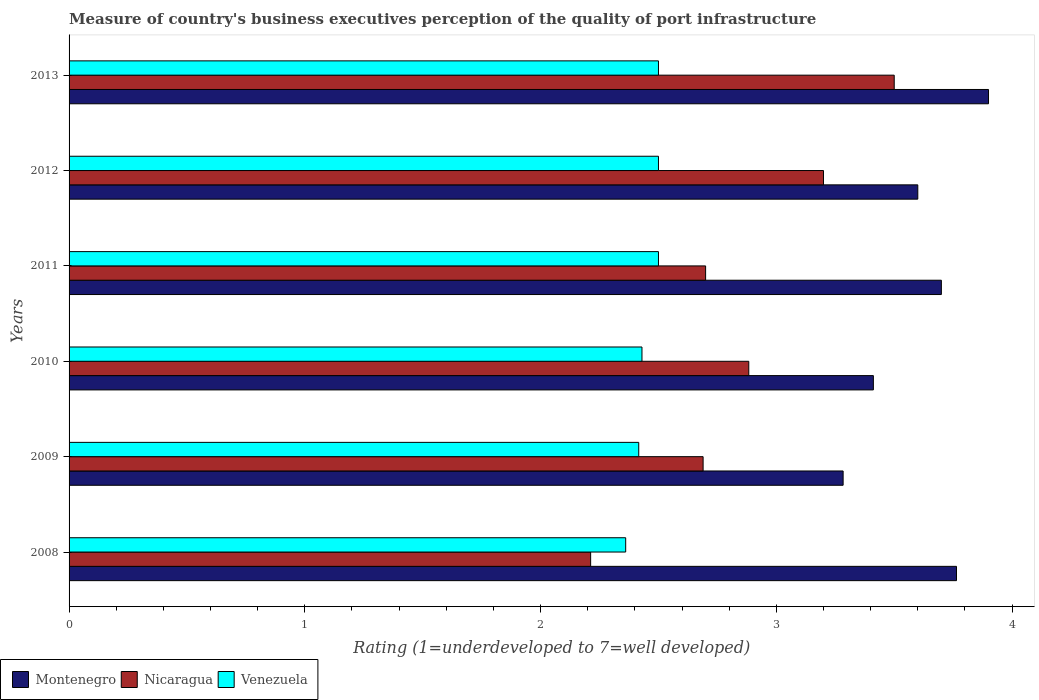How many different coloured bars are there?
Provide a short and direct response. 3. How many groups of bars are there?
Offer a terse response. 6. Are the number of bars per tick equal to the number of legend labels?
Make the answer very short. Yes. How many bars are there on the 2nd tick from the bottom?
Keep it short and to the point. 3. In how many cases, is the number of bars for a given year not equal to the number of legend labels?
Offer a very short reply. 0. What is the ratings of the quality of port infrastructure in Venezuela in 2008?
Your answer should be compact. 2.36. Across all years, what is the maximum ratings of the quality of port infrastructure in Nicaragua?
Keep it short and to the point. 3.5. Across all years, what is the minimum ratings of the quality of port infrastructure in Nicaragua?
Keep it short and to the point. 2.21. What is the total ratings of the quality of port infrastructure in Venezuela in the graph?
Your answer should be very brief. 14.71. What is the difference between the ratings of the quality of port infrastructure in Montenegro in 2012 and that in 2013?
Ensure brevity in your answer.  -0.3. What is the difference between the ratings of the quality of port infrastructure in Montenegro in 2011 and the ratings of the quality of port infrastructure in Nicaragua in 2013?
Offer a terse response. 0.2. What is the average ratings of the quality of port infrastructure in Montenegro per year?
Provide a short and direct response. 3.61. In the year 2012, what is the difference between the ratings of the quality of port infrastructure in Nicaragua and ratings of the quality of port infrastructure in Montenegro?
Offer a very short reply. -0.4. What is the ratio of the ratings of the quality of port infrastructure in Montenegro in 2009 to that in 2012?
Offer a terse response. 0.91. What is the difference between the highest and the second highest ratings of the quality of port infrastructure in Nicaragua?
Ensure brevity in your answer.  0.3. What is the difference between the highest and the lowest ratings of the quality of port infrastructure in Nicaragua?
Your answer should be very brief. 1.29. In how many years, is the ratings of the quality of port infrastructure in Nicaragua greater than the average ratings of the quality of port infrastructure in Nicaragua taken over all years?
Provide a short and direct response. 3. What does the 3rd bar from the top in 2012 represents?
Ensure brevity in your answer.  Montenegro. What does the 2nd bar from the bottom in 2013 represents?
Your answer should be compact. Nicaragua. How many years are there in the graph?
Provide a short and direct response. 6. Are the values on the major ticks of X-axis written in scientific E-notation?
Provide a succinct answer. No. Does the graph contain any zero values?
Provide a succinct answer. No. Does the graph contain grids?
Offer a terse response. No. Where does the legend appear in the graph?
Keep it short and to the point. Bottom left. How many legend labels are there?
Your answer should be very brief. 3. How are the legend labels stacked?
Ensure brevity in your answer.  Horizontal. What is the title of the graph?
Ensure brevity in your answer.  Measure of country's business executives perception of the quality of port infrastructure. Does "Gambia, The" appear as one of the legend labels in the graph?
Your answer should be very brief. No. What is the label or title of the X-axis?
Keep it short and to the point. Rating (1=underdeveloped to 7=well developed). What is the label or title of the Y-axis?
Make the answer very short. Years. What is the Rating (1=underdeveloped to 7=well developed) in Montenegro in 2008?
Provide a succinct answer. 3.76. What is the Rating (1=underdeveloped to 7=well developed) in Nicaragua in 2008?
Make the answer very short. 2.21. What is the Rating (1=underdeveloped to 7=well developed) in Venezuela in 2008?
Ensure brevity in your answer.  2.36. What is the Rating (1=underdeveloped to 7=well developed) in Montenegro in 2009?
Ensure brevity in your answer.  3.28. What is the Rating (1=underdeveloped to 7=well developed) of Nicaragua in 2009?
Offer a terse response. 2.69. What is the Rating (1=underdeveloped to 7=well developed) of Venezuela in 2009?
Offer a very short reply. 2.42. What is the Rating (1=underdeveloped to 7=well developed) in Montenegro in 2010?
Your response must be concise. 3.41. What is the Rating (1=underdeveloped to 7=well developed) of Nicaragua in 2010?
Your answer should be very brief. 2.88. What is the Rating (1=underdeveloped to 7=well developed) in Venezuela in 2010?
Offer a terse response. 2.43. What is the Rating (1=underdeveloped to 7=well developed) in Venezuela in 2011?
Make the answer very short. 2.5. What is the Rating (1=underdeveloped to 7=well developed) of Venezuela in 2012?
Your response must be concise. 2.5. Across all years, what is the maximum Rating (1=underdeveloped to 7=well developed) in Nicaragua?
Your answer should be very brief. 3.5. Across all years, what is the maximum Rating (1=underdeveloped to 7=well developed) of Venezuela?
Provide a short and direct response. 2.5. Across all years, what is the minimum Rating (1=underdeveloped to 7=well developed) in Montenegro?
Make the answer very short. 3.28. Across all years, what is the minimum Rating (1=underdeveloped to 7=well developed) in Nicaragua?
Offer a very short reply. 2.21. Across all years, what is the minimum Rating (1=underdeveloped to 7=well developed) of Venezuela?
Ensure brevity in your answer.  2.36. What is the total Rating (1=underdeveloped to 7=well developed) of Montenegro in the graph?
Your answer should be very brief. 21.66. What is the total Rating (1=underdeveloped to 7=well developed) of Nicaragua in the graph?
Provide a succinct answer. 17.18. What is the total Rating (1=underdeveloped to 7=well developed) of Venezuela in the graph?
Your answer should be compact. 14.71. What is the difference between the Rating (1=underdeveloped to 7=well developed) of Montenegro in 2008 and that in 2009?
Ensure brevity in your answer.  0.48. What is the difference between the Rating (1=underdeveloped to 7=well developed) of Nicaragua in 2008 and that in 2009?
Offer a very short reply. -0.48. What is the difference between the Rating (1=underdeveloped to 7=well developed) in Venezuela in 2008 and that in 2009?
Provide a succinct answer. -0.06. What is the difference between the Rating (1=underdeveloped to 7=well developed) in Montenegro in 2008 and that in 2010?
Your answer should be very brief. 0.35. What is the difference between the Rating (1=underdeveloped to 7=well developed) of Nicaragua in 2008 and that in 2010?
Offer a terse response. -0.67. What is the difference between the Rating (1=underdeveloped to 7=well developed) of Venezuela in 2008 and that in 2010?
Your answer should be very brief. -0.07. What is the difference between the Rating (1=underdeveloped to 7=well developed) of Montenegro in 2008 and that in 2011?
Your answer should be compact. 0.06. What is the difference between the Rating (1=underdeveloped to 7=well developed) of Nicaragua in 2008 and that in 2011?
Provide a short and direct response. -0.49. What is the difference between the Rating (1=underdeveloped to 7=well developed) in Venezuela in 2008 and that in 2011?
Ensure brevity in your answer.  -0.14. What is the difference between the Rating (1=underdeveloped to 7=well developed) of Montenegro in 2008 and that in 2012?
Keep it short and to the point. 0.16. What is the difference between the Rating (1=underdeveloped to 7=well developed) in Nicaragua in 2008 and that in 2012?
Keep it short and to the point. -0.99. What is the difference between the Rating (1=underdeveloped to 7=well developed) of Venezuela in 2008 and that in 2012?
Offer a very short reply. -0.14. What is the difference between the Rating (1=underdeveloped to 7=well developed) of Montenegro in 2008 and that in 2013?
Provide a succinct answer. -0.14. What is the difference between the Rating (1=underdeveloped to 7=well developed) in Nicaragua in 2008 and that in 2013?
Keep it short and to the point. -1.29. What is the difference between the Rating (1=underdeveloped to 7=well developed) of Venezuela in 2008 and that in 2013?
Keep it short and to the point. -0.14. What is the difference between the Rating (1=underdeveloped to 7=well developed) in Montenegro in 2009 and that in 2010?
Keep it short and to the point. -0.13. What is the difference between the Rating (1=underdeveloped to 7=well developed) of Nicaragua in 2009 and that in 2010?
Your answer should be very brief. -0.19. What is the difference between the Rating (1=underdeveloped to 7=well developed) in Venezuela in 2009 and that in 2010?
Keep it short and to the point. -0.01. What is the difference between the Rating (1=underdeveloped to 7=well developed) of Montenegro in 2009 and that in 2011?
Offer a terse response. -0.42. What is the difference between the Rating (1=underdeveloped to 7=well developed) in Nicaragua in 2009 and that in 2011?
Provide a succinct answer. -0.01. What is the difference between the Rating (1=underdeveloped to 7=well developed) in Venezuela in 2009 and that in 2011?
Keep it short and to the point. -0.08. What is the difference between the Rating (1=underdeveloped to 7=well developed) of Montenegro in 2009 and that in 2012?
Give a very brief answer. -0.32. What is the difference between the Rating (1=underdeveloped to 7=well developed) in Nicaragua in 2009 and that in 2012?
Provide a short and direct response. -0.51. What is the difference between the Rating (1=underdeveloped to 7=well developed) of Venezuela in 2009 and that in 2012?
Make the answer very short. -0.08. What is the difference between the Rating (1=underdeveloped to 7=well developed) of Montenegro in 2009 and that in 2013?
Ensure brevity in your answer.  -0.62. What is the difference between the Rating (1=underdeveloped to 7=well developed) in Nicaragua in 2009 and that in 2013?
Make the answer very short. -0.81. What is the difference between the Rating (1=underdeveloped to 7=well developed) in Venezuela in 2009 and that in 2013?
Give a very brief answer. -0.08. What is the difference between the Rating (1=underdeveloped to 7=well developed) in Montenegro in 2010 and that in 2011?
Provide a succinct answer. -0.29. What is the difference between the Rating (1=underdeveloped to 7=well developed) of Nicaragua in 2010 and that in 2011?
Offer a terse response. 0.18. What is the difference between the Rating (1=underdeveloped to 7=well developed) of Venezuela in 2010 and that in 2011?
Your answer should be compact. -0.07. What is the difference between the Rating (1=underdeveloped to 7=well developed) in Montenegro in 2010 and that in 2012?
Your answer should be compact. -0.19. What is the difference between the Rating (1=underdeveloped to 7=well developed) in Nicaragua in 2010 and that in 2012?
Give a very brief answer. -0.32. What is the difference between the Rating (1=underdeveloped to 7=well developed) of Venezuela in 2010 and that in 2012?
Offer a terse response. -0.07. What is the difference between the Rating (1=underdeveloped to 7=well developed) of Montenegro in 2010 and that in 2013?
Give a very brief answer. -0.49. What is the difference between the Rating (1=underdeveloped to 7=well developed) of Nicaragua in 2010 and that in 2013?
Your answer should be very brief. -0.62. What is the difference between the Rating (1=underdeveloped to 7=well developed) of Venezuela in 2010 and that in 2013?
Provide a succinct answer. -0.07. What is the difference between the Rating (1=underdeveloped to 7=well developed) of Montenegro in 2011 and that in 2012?
Your answer should be compact. 0.1. What is the difference between the Rating (1=underdeveloped to 7=well developed) of Nicaragua in 2011 and that in 2012?
Offer a very short reply. -0.5. What is the difference between the Rating (1=underdeveloped to 7=well developed) of Venezuela in 2011 and that in 2012?
Offer a very short reply. 0. What is the difference between the Rating (1=underdeveloped to 7=well developed) of Montenegro in 2011 and that in 2013?
Your answer should be compact. -0.2. What is the difference between the Rating (1=underdeveloped to 7=well developed) of Nicaragua in 2011 and that in 2013?
Provide a short and direct response. -0.8. What is the difference between the Rating (1=underdeveloped to 7=well developed) of Venezuela in 2012 and that in 2013?
Make the answer very short. 0. What is the difference between the Rating (1=underdeveloped to 7=well developed) in Montenegro in 2008 and the Rating (1=underdeveloped to 7=well developed) in Nicaragua in 2009?
Provide a short and direct response. 1.07. What is the difference between the Rating (1=underdeveloped to 7=well developed) in Montenegro in 2008 and the Rating (1=underdeveloped to 7=well developed) in Venezuela in 2009?
Give a very brief answer. 1.35. What is the difference between the Rating (1=underdeveloped to 7=well developed) of Nicaragua in 2008 and the Rating (1=underdeveloped to 7=well developed) of Venezuela in 2009?
Provide a short and direct response. -0.2. What is the difference between the Rating (1=underdeveloped to 7=well developed) of Montenegro in 2008 and the Rating (1=underdeveloped to 7=well developed) of Nicaragua in 2010?
Your answer should be compact. 0.88. What is the difference between the Rating (1=underdeveloped to 7=well developed) in Montenegro in 2008 and the Rating (1=underdeveloped to 7=well developed) in Venezuela in 2010?
Provide a succinct answer. 1.33. What is the difference between the Rating (1=underdeveloped to 7=well developed) in Nicaragua in 2008 and the Rating (1=underdeveloped to 7=well developed) in Venezuela in 2010?
Ensure brevity in your answer.  -0.22. What is the difference between the Rating (1=underdeveloped to 7=well developed) of Montenegro in 2008 and the Rating (1=underdeveloped to 7=well developed) of Nicaragua in 2011?
Ensure brevity in your answer.  1.06. What is the difference between the Rating (1=underdeveloped to 7=well developed) in Montenegro in 2008 and the Rating (1=underdeveloped to 7=well developed) in Venezuela in 2011?
Offer a very short reply. 1.26. What is the difference between the Rating (1=underdeveloped to 7=well developed) of Nicaragua in 2008 and the Rating (1=underdeveloped to 7=well developed) of Venezuela in 2011?
Offer a very short reply. -0.29. What is the difference between the Rating (1=underdeveloped to 7=well developed) of Montenegro in 2008 and the Rating (1=underdeveloped to 7=well developed) of Nicaragua in 2012?
Your response must be concise. 0.56. What is the difference between the Rating (1=underdeveloped to 7=well developed) of Montenegro in 2008 and the Rating (1=underdeveloped to 7=well developed) of Venezuela in 2012?
Provide a short and direct response. 1.26. What is the difference between the Rating (1=underdeveloped to 7=well developed) in Nicaragua in 2008 and the Rating (1=underdeveloped to 7=well developed) in Venezuela in 2012?
Provide a succinct answer. -0.29. What is the difference between the Rating (1=underdeveloped to 7=well developed) of Montenegro in 2008 and the Rating (1=underdeveloped to 7=well developed) of Nicaragua in 2013?
Your answer should be very brief. 0.26. What is the difference between the Rating (1=underdeveloped to 7=well developed) of Montenegro in 2008 and the Rating (1=underdeveloped to 7=well developed) of Venezuela in 2013?
Your answer should be very brief. 1.26. What is the difference between the Rating (1=underdeveloped to 7=well developed) of Nicaragua in 2008 and the Rating (1=underdeveloped to 7=well developed) of Venezuela in 2013?
Ensure brevity in your answer.  -0.29. What is the difference between the Rating (1=underdeveloped to 7=well developed) of Montenegro in 2009 and the Rating (1=underdeveloped to 7=well developed) of Nicaragua in 2010?
Your answer should be compact. 0.4. What is the difference between the Rating (1=underdeveloped to 7=well developed) of Montenegro in 2009 and the Rating (1=underdeveloped to 7=well developed) of Venezuela in 2010?
Offer a very short reply. 0.85. What is the difference between the Rating (1=underdeveloped to 7=well developed) in Nicaragua in 2009 and the Rating (1=underdeveloped to 7=well developed) in Venezuela in 2010?
Offer a very short reply. 0.26. What is the difference between the Rating (1=underdeveloped to 7=well developed) in Montenegro in 2009 and the Rating (1=underdeveloped to 7=well developed) in Nicaragua in 2011?
Give a very brief answer. 0.58. What is the difference between the Rating (1=underdeveloped to 7=well developed) of Montenegro in 2009 and the Rating (1=underdeveloped to 7=well developed) of Venezuela in 2011?
Make the answer very short. 0.78. What is the difference between the Rating (1=underdeveloped to 7=well developed) of Nicaragua in 2009 and the Rating (1=underdeveloped to 7=well developed) of Venezuela in 2011?
Your response must be concise. 0.19. What is the difference between the Rating (1=underdeveloped to 7=well developed) of Montenegro in 2009 and the Rating (1=underdeveloped to 7=well developed) of Nicaragua in 2012?
Make the answer very short. 0.08. What is the difference between the Rating (1=underdeveloped to 7=well developed) of Montenegro in 2009 and the Rating (1=underdeveloped to 7=well developed) of Venezuela in 2012?
Offer a very short reply. 0.78. What is the difference between the Rating (1=underdeveloped to 7=well developed) in Nicaragua in 2009 and the Rating (1=underdeveloped to 7=well developed) in Venezuela in 2012?
Keep it short and to the point. 0.19. What is the difference between the Rating (1=underdeveloped to 7=well developed) in Montenegro in 2009 and the Rating (1=underdeveloped to 7=well developed) in Nicaragua in 2013?
Your answer should be very brief. -0.22. What is the difference between the Rating (1=underdeveloped to 7=well developed) of Montenegro in 2009 and the Rating (1=underdeveloped to 7=well developed) of Venezuela in 2013?
Your response must be concise. 0.78. What is the difference between the Rating (1=underdeveloped to 7=well developed) of Nicaragua in 2009 and the Rating (1=underdeveloped to 7=well developed) of Venezuela in 2013?
Your answer should be very brief. 0.19. What is the difference between the Rating (1=underdeveloped to 7=well developed) in Montenegro in 2010 and the Rating (1=underdeveloped to 7=well developed) in Nicaragua in 2011?
Provide a short and direct response. 0.71. What is the difference between the Rating (1=underdeveloped to 7=well developed) in Montenegro in 2010 and the Rating (1=underdeveloped to 7=well developed) in Venezuela in 2011?
Offer a terse response. 0.91. What is the difference between the Rating (1=underdeveloped to 7=well developed) of Nicaragua in 2010 and the Rating (1=underdeveloped to 7=well developed) of Venezuela in 2011?
Your response must be concise. 0.38. What is the difference between the Rating (1=underdeveloped to 7=well developed) of Montenegro in 2010 and the Rating (1=underdeveloped to 7=well developed) of Nicaragua in 2012?
Your answer should be very brief. 0.21. What is the difference between the Rating (1=underdeveloped to 7=well developed) in Montenegro in 2010 and the Rating (1=underdeveloped to 7=well developed) in Venezuela in 2012?
Your response must be concise. 0.91. What is the difference between the Rating (1=underdeveloped to 7=well developed) in Nicaragua in 2010 and the Rating (1=underdeveloped to 7=well developed) in Venezuela in 2012?
Make the answer very short. 0.38. What is the difference between the Rating (1=underdeveloped to 7=well developed) of Montenegro in 2010 and the Rating (1=underdeveloped to 7=well developed) of Nicaragua in 2013?
Give a very brief answer. -0.09. What is the difference between the Rating (1=underdeveloped to 7=well developed) of Montenegro in 2010 and the Rating (1=underdeveloped to 7=well developed) of Venezuela in 2013?
Keep it short and to the point. 0.91. What is the difference between the Rating (1=underdeveloped to 7=well developed) in Nicaragua in 2010 and the Rating (1=underdeveloped to 7=well developed) in Venezuela in 2013?
Give a very brief answer. 0.38. What is the difference between the Rating (1=underdeveloped to 7=well developed) in Montenegro in 2011 and the Rating (1=underdeveloped to 7=well developed) in Venezuela in 2013?
Offer a very short reply. 1.2. What is the difference between the Rating (1=underdeveloped to 7=well developed) of Nicaragua in 2011 and the Rating (1=underdeveloped to 7=well developed) of Venezuela in 2013?
Your response must be concise. 0.2. What is the difference between the Rating (1=underdeveloped to 7=well developed) of Montenegro in 2012 and the Rating (1=underdeveloped to 7=well developed) of Nicaragua in 2013?
Ensure brevity in your answer.  0.1. What is the difference between the Rating (1=underdeveloped to 7=well developed) in Nicaragua in 2012 and the Rating (1=underdeveloped to 7=well developed) in Venezuela in 2013?
Keep it short and to the point. 0.7. What is the average Rating (1=underdeveloped to 7=well developed) in Montenegro per year?
Your answer should be very brief. 3.61. What is the average Rating (1=underdeveloped to 7=well developed) in Nicaragua per year?
Give a very brief answer. 2.86. What is the average Rating (1=underdeveloped to 7=well developed) of Venezuela per year?
Ensure brevity in your answer.  2.45. In the year 2008, what is the difference between the Rating (1=underdeveloped to 7=well developed) in Montenegro and Rating (1=underdeveloped to 7=well developed) in Nicaragua?
Keep it short and to the point. 1.55. In the year 2008, what is the difference between the Rating (1=underdeveloped to 7=well developed) of Montenegro and Rating (1=underdeveloped to 7=well developed) of Venezuela?
Provide a succinct answer. 1.4. In the year 2008, what is the difference between the Rating (1=underdeveloped to 7=well developed) in Nicaragua and Rating (1=underdeveloped to 7=well developed) in Venezuela?
Keep it short and to the point. -0.15. In the year 2009, what is the difference between the Rating (1=underdeveloped to 7=well developed) of Montenegro and Rating (1=underdeveloped to 7=well developed) of Nicaragua?
Your response must be concise. 0.59. In the year 2009, what is the difference between the Rating (1=underdeveloped to 7=well developed) in Montenegro and Rating (1=underdeveloped to 7=well developed) in Venezuela?
Ensure brevity in your answer.  0.87. In the year 2009, what is the difference between the Rating (1=underdeveloped to 7=well developed) in Nicaragua and Rating (1=underdeveloped to 7=well developed) in Venezuela?
Give a very brief answer. 0.27. In the year 2010, what is the difference between the Rating (1=underdeveloped to 7=well developed) of Montenegro and Rating (1=underdeveloped to 7=well developed) of Nicaragua?
Offer a terse response. 0.53. In the year 2010, what is the difference between the Rating (1=underdeveloped to 7=well developed) of Montenegro and Rating (1=underdeveloped to 7=well developed) of Venezuela?
Provide a short and direct response. 0.98. In the year 2010, what is the difference between the Rating (1=underdeveloped to 7=well developed) of Nicaragua and Rating (1=underdeveloped to 7=well developed) of Venezuela?
Your answer should be compact. 0.45. In the year 2011, what is the difference between the Rating (1=underdeveloped to 7=well developed) of Montenegro and Rating (1=underdeveloped to 7=well developed) of Nicaragua?
Offer a very short reply. 1. In the year 2011, what is the difference between the Rating (1=underdeveloped to 7=well developed) in Montenegro and Rating (1=underdeveloped to 7=well developed) in Venezuela?
Make the answer very short. 1.2. In the year 2012, what is the difference between the Rating (1=underdeveloped to 7=well developed) of Montenegro and Rating (1=underdeveloped to 7=well developed) of Nicaragua?
Your response must be concise. 0.4. In the year 2012, what is the difference between the Rating (1=underdeveloped to 7=well developed) of Nicaragua and Rating (1=underdeveloped to 7=well developed) of Venezuela?
Ensure brevity in your answer.  0.7. In the year 2013, what is the difference between the Rating (1=underdeveloped to 7=well developed) of Montenegro and Rating (1=underdeveloped to 7=well developed) of Nicaragua?
Your response must be concise. 0.4. In the year 2013, what is the difference between the Rating (1=underdeveloped to 7=well developed) of Nicaragua and Rating (1=underdeveloped to 7=well developed) of Venezuela?
Your response must be concise. 1. What is the ratio of the Rating (1=underdeveloped to 7=well developed) in Montenegro in 2008 to that in 2009?
Provide a short and direct response. 1.15. What is the ratio of the Rating (1=underdeveloped to 7=well developed) in Nicaragua in 2008 to that in 2009?
Your answer should be very brief. 0.82. What is the ratio of the Rating (1=underdeveloped to 7=well developed) in Venezuela in 2008 to that in 2009?
Your response must be concise. 0.98. What is the ratio of the Rating (1=underdeveloped to 7=well developed) in Montenegro in 2008 to that in 2010?
Give a very brief answer. 1.1. What is the ratio of the Rating (1=underdeveloped to 7=well developed) of Nicaragua in 2008 to that in 2010?
Make the answer very short. 0.77. What is the ratio of the Rating (1=underdeveloped to 7=well developed) of Venezuela in 2008 to that in 2010?
Keep it short and to the point. 0.97. What is the ratio of the Rating (1=underdeveloped to 7=well developed) in Montenegro in 2008 to that in 2011?
Your answer should be compact. 1.02. What is the ratio of the Rating (1=underdeveloped to 7=well developed) of Nicaragua in 2008 to that in 2011?
Offer a terse response. 0.82. What is the ratio of the Rating (1=underdeveloped to 7=well developed) in Venezuela in 2008 to that in 2011?
Your response must be concise. 0.94. What is the ratio of the Rating (1=underdeveloped to 7=well developed) in Montenegro in 2008 to that in 2012?
Make the answer very short. 1.05. What is the ratio of the Rating (1=underdeveloped to 7=well developed) in Nicaragua in 2008 to that in 2012?
Ensure brevity in your answer.  0.69. What is the ratio of the Rating (1=underdeveloped to 7=well developed) of Venezuela in 2008 to that in 2012?
Give a very brief answer. 0.94. What is the ratio of the Rating (1=underdeveloped to 7=well developed) of Montenegro in 2008 to that in 2013?
Ensure brevity in your answer.  0.97. What is the ratio of the Rating (1=underdeveloped to 7=well developed) of Nicaragua in 2008 to that in 2013?
Ensure brevity in your answer.  0.63. What is the ratio of the Rating (1=underdeveloped to 7=well developed) in Venezuela in 2008 to that in 2013?
Your answer should be very brief. 0.94. What is the ratio of the Rating (1=underdeveloped to 7=well developed) of Montenegro in 2009 to that in 2010?
Ensure brevity in your answer.  0.96. What is the ratio of the Rating (1=underdeveloped to 7=well developed) in Nicaragua in 2009 to that in 2010?
Your answer should be very brief. 0.93. What is the ratio of the Rating (1=underdeveloped to 7=well developed) of Venezuela in 2009 to that in 2010?
Offer a very short reply. 0.99. What is the ratio of the Rating (1=underdeveloped to 7=well developed) of Montenegro in 2009 to that in 2011?
Your response must be concise. 0.89. What is the ratio of the Rating (1=underdeveloped to 7=well developed) in Nicaragua in 2009 to that in 2011?
Ensure brevity in your answer.  1. What is the ratio of the Rating (1=underdeveloped to 7=well developed) of Venezuela in 2009 to that in 2011?
Make the answer very short. 0.97. What is the ratio of the Rating (1=underdeveloped to 7=well developed) in Montenegro in 2009 to that in 2012?
Provide a short and direct response. 0.91. What is the ratio of the Rating (1=underdeveloped to 7=well developed) of Nicaragua in 2009 to that in 2012?
Keep it short and to the point. 0.84. What is the ratio of the Rating (1=underdeveloped to 7=well developed) of Venezuela in 2009 to that in 2012?
Offer a very short reply. 0.97. What is the ratio of the Rating (1=underdeveloped to 7=well developed) in Montenegro in 2009 to that in 2013?
Offer a terse response. 0.84. What is the ratio of the Rating (1=underdeveloped to 7=well developed) of Nicaragua in 2009 to that in 2013?
Make the answer very short. 0.77. What is the ratio of the Rating (1=underdeveloped to 7=well developed) of Venezuela in 2009 to that in 2013?
Keep it short and to the point. 0.97. What is the ratio of the Rating (1=underdeveloped to 7=well developed) in Montenegro in 2010 to that in 2011?
Provide a short and direct response. 0.92. What is the ratio of the Rating (1=underdeveloped to 7=well developed) in Nicaragua in 2010 to that in 2011?
Ensure brevity in your answer.  1.07. What is the ratio of the Rating (1=underdeveloped to 7=well developed) of Venezuela in 2010 to that in 2011?
Offer a very short reply. 0.97. What is the ratio of the Rating (1=underdeveloped to 7=well developed) of Montenegro in 2010 to that in 2012?
Your answer should be very brief. 0.95. What is the ratio of the Rating (1=underdeveloped to 7=well developed) of Nicaragua in 2010 to that in 2012?
Make the answer very short. 0.9. What is the ratio of the Rating (1=underdeveloped to 7=well developed) in Venezuela in 2010 to that in 2012?
Keep it short and to the point. 0.97. What is the ratio of the Rating (1=underdeveloped to 7=well developed) in Montenegro in 2010 to that in 2013?
Make the answer very short. 0.87. What is the ratio of the Rating (1=underdeveloped to 7=well developed) of Nicaragua in 2010 to that in 2013?
Give a very brief answer. 0.82. What is the ratio of the Rating (1=underdeveloped to 7=well developed) of Venezuela in 2010 to that in 2013?
Offer a very short reply. 0.97. What is the ratio of the Rating (1=underdeveloped to 7=well developed) in Montenegro in 2011 to that in 2012?
Keep it short and to the point. 1.03. What is the ratio of the Rating (1=underdeveloped to 7=well developed) of Nicaragua in 2011 to that in 2012?
Your answer should be very brief. 0.84. What is the ratio of the Rating (1=underdeveloped to 7=well developed) of Montenegro in 2011 to that in 2013?
Make the answer very short. 0.95. What is the ratio of the Rating (1=underdeveloped to 7=well developed) of Nicaragua in 2011 to that in 2013?
Your answer should be very brief. 0.77. What is the ratio of the Rating (1=underdeveloped to 7=well developed) in Venezuela in 2011 to that in 2013?
Provide a succinct answer. 1. What is the ratio of the Rating (1=underdeveloped to 7=well developed) of Nicaragua in 2012 to that in 2013?
Give a very brief answer. 0.91. What is the ratio of the Rating (1=underdeveloped to 7=well developed) of Venezuela in 2012 to that in 2013?
Offer a terse response. 1. What is the difference between the highest and the second highest Rating (1=underdeveloped to 7=well developed) in Montenegro?
Offer a very short reply. 0.14. What is the difference between the highest and the second highest Rating (1=underdeveloped to 7=well developed) of Nicaragua?
Your answer should be very brief. 0.3. What is the difference between the highest and the second highest Rating (1=underdeveloped to 7=well developed) of Venezuela?
Provide a short and direct response. 0. What is the difference between the highest and the lowest Rating (1=underdeveloped to 7=well developed) in Montenegro?
Your answer should be very brief. 0.62. What is the difference between the highest and the lowest Rating (1=underdeveloped to 7=well developed) of Nicaragua?
Offer a very short reply. 1.29. What is the difference between the highest and the lowest Rating (1=underdeveloped to 7=well developed) in Venezuela?
Provide a succinct answer. 0.14. 